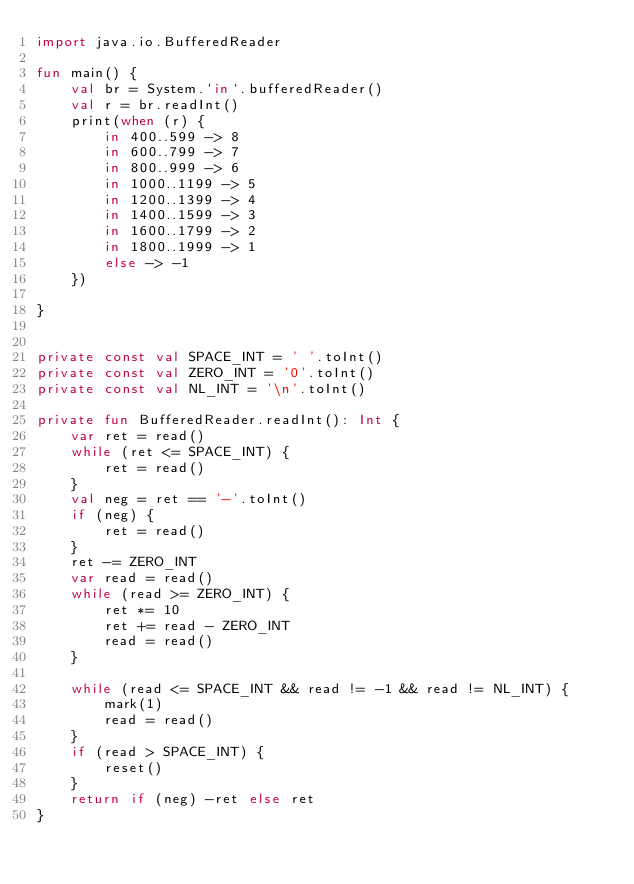Convert code to text. <code><loc_0><loc_0><loc_500><loc_500><_Kotlin_>import java.io.BufferedReader

fun main() {
    val br = System.`in`.bufferedReader()
    val r = br.readInt()
    print(when (r) {
        in 400..599 -> 8
        in 600..799 -> 7
        in 800..999 -> 6
        in 1000..1199 -> 5
        in 1200..1399 -> 4
        in 1400..1599 -> 3
        in 1600..1799 -> 2
        in 1800..1999 -> 1
        else -> -1
    })

}


private const val SPACE_INT = ' '.toInt()
private const val ZERO_INT = '0'.toInt()
private const val NL_INT = '\n'.toInt()

private fun BufferedReader.readInt(): Int {
    var ret = read()
    while (ret <= SPACE_INT) {
        ret = read()
    }
    val neg = ret == '-'.toInt()
    if (neg) {
        ret = read()
    }
    ret -= ZERO_INT
    var read = read()
    while (read >= ZERO_INT) {
        ret *= 10
        ret += read - ZERO_INT
        read = read()
    }

    while (read <= SPACE_INT && read != -1 && read != NL_INT) {
        mark(1)
        read = read()
    }
    if (read > SPACE_INT) {
        reset()
    }
    return if (neg) -ret else ret
}</code> 